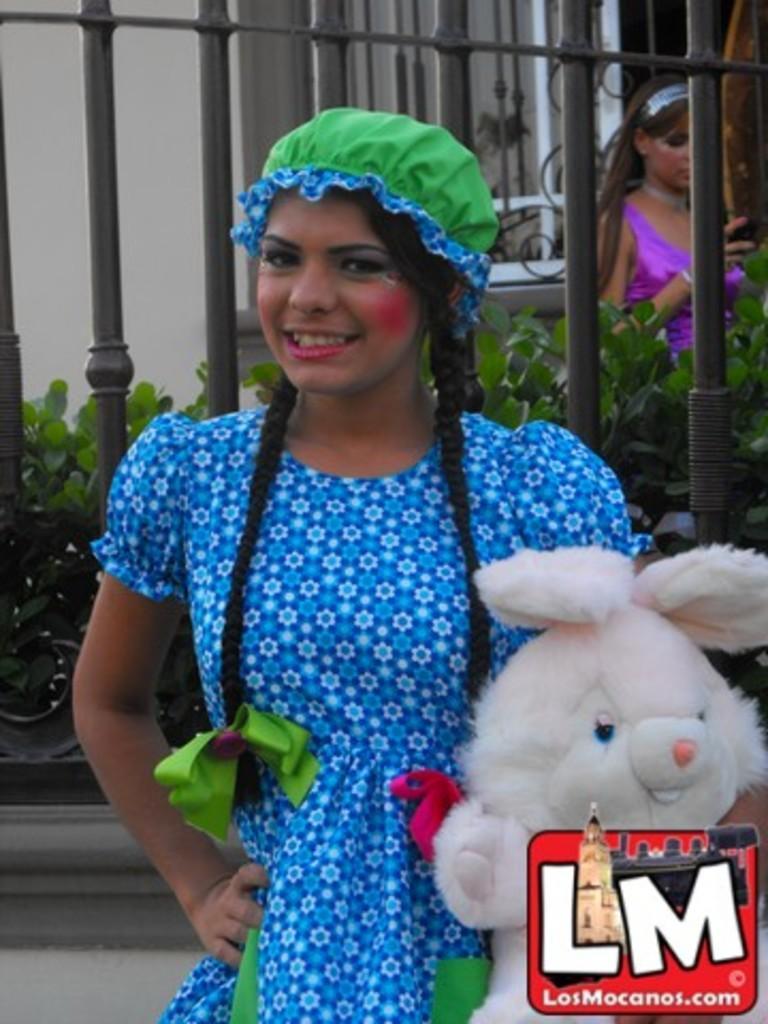In one or two sentences, can you explain what this image depicts? In this picture, there is a woman holding a toy. She is wearing a blue dress and green cap. Behind her, there are iron poles and plants. On the top right, there is a woman in purple dress. 